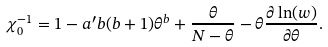<formula> <loc_0><loc_0><loc_500><loc_500>\chi _ { 0 } ^ { - 1 } = 1 - a ^ { \prime } b ( b + 1 ) \theta ^ { b } + \frac { \theta } { N - \theta } - \theta \frac { \partial \ln ( w ) } { \partial \theta } .</formula> 